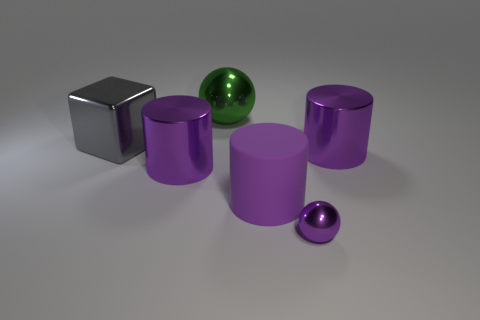Add 1 large blocks. How many objects exist? 7 Subtract all cubes. How many objects are left? 5 Add 4 metal objects. How many metal objects are left? 9 Add 5 big green things. How many big green things exist? 6 Subtract 2 purple cylinders. How many objects are left? 4 Subtract all green cylinders. Subtract all big cylinders. How many objects are left? 3 